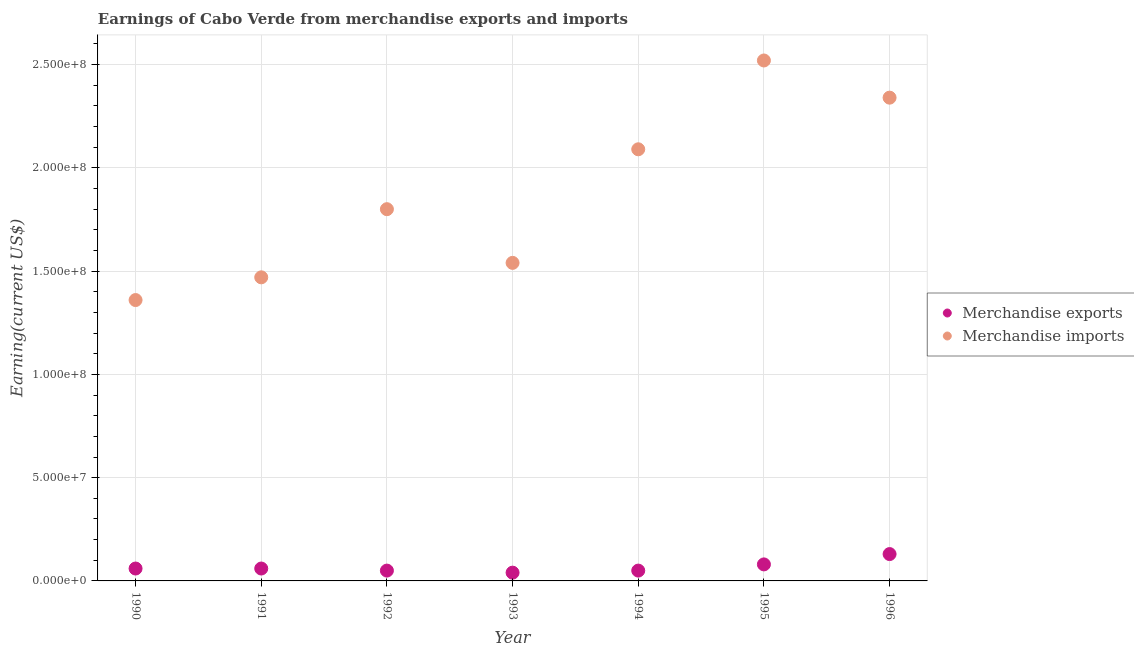How many different coloured dotlines are there?
Your answer should be compact. 2. Is the number of dotlines equal to the number of legend labels?
Make the answer very short. Yes. What is the earnings from merchandise imports in 1991?
Offer a very short reply. 1.47e+08. Across all years, what is the maximum earnings from merchandise exports?
Offer a terse response. 1.30e+07. Across all years, what is the minimum earnings from merchandise exports?
Your answer should be compact. 4.00e+06. In which year was the earnings from merchandise exports maximum?
Ensure brevity in your answer.  1996. In which year was the earnings from merchandise imports minimum?
Your answer should be compact. 1990. What is the total earnings from merchandise imports in the graph?
Your answer should be compact. 1.31e+09. What is the difference between the earnings from merchandise imports in 1992 and that in 1994?
Provide a succinct answer. -2.90e+07. What is the difference between the earnings from merchandise imports in 1990 and the earnings from merchandise exports in 1996?
Offer a very short reply. 1.23e+08. What is the average earnings from merchandise exports per year?
Offer a very short reply. 6.71e+06. In the year 1996, what is the difference between the earnings from merchandise exports and earnings from merchandise imports?
Keep it short and to the point. -2.21e+08. What is the difference between the highest and the lowest earnings from merchandise imports?
Offer a very short reply. 1.16e+08. Is the sum of the earnings from merchandise exports in 1991 and 1996 greater than the maximum earnings from merchandise imports across all years?
Provide a succinct answer. No. Does the earnings from merchandise exports monotonically increase over the years?
Offer a very short reply. No. Is the earnings from merchandise exports strictly less than the earnings from merchandise imports over the years?
Keep it short and to the point. Yes. How many dotlines are there?
Your answer should be very brief. 2. Does the graph contain any zero values?
Ensure brevity in your answer.  No. Where does the legend appear in the graph?
Give a very brief answer. Center right. How many legend labels are there?
Make the answer very short. 2. What is the title of the graph?
Ensure brevity in your answer.  Earnings of Cabo Verde from merchandise exports and imports. What is the label or title of the X-axis?
Your answer should be compact. Year. What is the label or title of the Y-axis?
Offer a terse response. Earning(current US$). What is the Earning(current US$) of Merchandise imports in 1990?
Provide a succinct answer. 1.36e+08. What is the Earning(current US$) in Merchandise imports in 1991?
Your response must be concise. 1.47e+08. What is the Earning(current US$) of Merchandise exports in 1992?
Your answer should be very brief. 5.00e+06. What is the Earning(current US$) in Merchandise imports in 1992?
Ensure brevity in your answer.  1.80e+08. What is the Earning(current US$) of Merchandise exports in 1993?
Your response must be concise. 4.00e+06. What is the Earning(current US$) in Merchandise imports in 1993?
Your answer should be very brief. 1.54e+08. What is the Earning(current US$) of Merchandise imports in 1994?
Provide a succinct answer. 2.09e+08. What is the Earning(current US$) of Merchandise imports in 1995?
Your answer should be compact. 2.52e+08. What is the Earning(current US$) in Merchandise exports in 1996?
Keep it short and to the point. 1.30e+07. What is the Earning(current US$) of Merchandise imports in 1996?
Keep it short and to the point. 2.34e+08. Across all years, what is the maximum Earning(current US$) in Merchandise exports?
Keep it short and to the point. 1.30e+07. Across all years, what is the maximum Earning(current US$) in Merchandise imports?
Ensure brevity in your answer.  2.52e+08. Across all years, what is the minimum Earning(current US$) of Merchandise imports?
Your answer should be compact. 1.36e+08. What is the total Earning(current US$) in Merchandise exports in the graph?
Make the answer very short. 4.70e+07. What is the total Earning(current US$) of Merchandise imports in the graph?
Your answer should be very brief. 1.31e+09. What is the difference between the Earning(current US$) in Merchandise exports in 1990 and that in 1991?
Provide a short and direct response. 0. What is the difference between the Earning(current US$) in Merchandise imports in 1990 and that in 1991?
Provide a short and direct response. -1.10e+07. What is the difference between the Earning(current US$) of Merchandise exports in 1990 and that in 1992?
Ensure brevity in your answer.  1.00e+06. What is the difference between the Earning(current US$) of Merchandise imports in 1990 and that in 1992?
Your answer should be very brief. -4.40e+07. What is the difference between the Earning(current US$) in Merchandise exports in 1990 and that in 1993?
Keep it short and to the point. 2.00e+06. What is the difference between the Earning(current US$) in Merchandise imports in 1990 and that in 1993?
Offer a terse response. -1.80e+07. What is the difference between the Earning(current US$) in Merchandise imports in 1990 and that in 1994?
Your response must be concise. -7.30e+07. What is the difference between the Earning(current US$) in Merchandise imports in 1990 and that in 1995?
Provide a succinct answer. -1.16e+08. What is the difference between the Earning(current US$) in Merchandise exports in 1990 and that in 1996?
Give a very brief answer. -7.00e+06. What is the difference between the Earning(current US$) in Merchandise imports in 1990 and that in 1996?
Your answer should be compact. -9.80e+07. What is the difference between the Earning(current US$) of Merchandise imports in 1991 and that in 1992?
Offer a very short reply. -3.30e+07. What is the difference between the Earning(current US$) in Merchandise exports in 1991 and that in 1993?
Provide a succinct answer. 2.00e+06. What is the difference between the Earning(current US$) in Merchandise imports in 1991 and that in 1993?
Offer a very short reply. -7.00e+06. What is the difference between the Earning(current US$) of Merchandise exports in 1991 and that in 1994?
Provide a short and direct response. 1.00e+06. What is the difference between the Earning(current US$) of Merchandise imports in 1991 and that in 1994?
Make the answer very short. -6.20e+07. What is the difference between the Earning(current US$) of Merchandise exports in 1991 and that in 1995?
Provide a short and direct response. -2.00e+06. What is the difference between the Earning(current US$) of Merchandise imports in 1991 and that in 1995?
Your response must be concise. -1.05e+08. What is the difference between the Earning(current US$) in Merchandise exports in 1991 and that in 1996?
Make the answer very short. -7.00e+06. What is the difference between the Earning(current US$) in Merchandise imports in 1991 and that in 1996?
Offer a very short reply. -8.70e+07. What is the difference between the Earning(current US$) of Merchandise exports in 1992 and that in 1993?
Your response must be concise. 1.00e+06. What is the difference between the Earning(current US$) in Merchandise imports in 1992 and that in 1993?
Offer a very short reply. 2.60e+07. What is the difference between the Earning(current US$) of Merchandise exports in 1992 and that in 1994?
Your response must be concise. 0. What is the difference between the Earning(current US$) of Merchandise imports in 1992 and that in 1994?
Offer a very short reply. -2.90e+07. What is the difference between the Earning(current US$) of Merchandise imports in 1992 and that in 1995?
Offer a very short reply. -7.20e+07. What is the difference between the Earning(current US$) of Merchandise exports in 1992 and that in 1996?
Provide a succinct answer. -8.00e+06. What is the difference between the Earning(current US$) of Merchandise imports in 1992 and that in 1996?
Give a very brief answer. -5.40e+07. What is the difference between the Earning(current US$) in Merchandise imports in 1993 and that in 1994?
Your response must be concise. -5.50e+07. What is the difference between the Earning(current US$) in Merchandise exports in 1993 and that in 1995?
Keep it short and to the point. -4.00e+06. What is the difference between the Earning(current US$) of Merchandise imports in 1993 and that in 1995?
Offer a very short reply. -9.80e+07. What is the difference between the Earning(current US$) of Merchandise exports in 1993 and that in 1996?
Ensure brevity in your answer.  -9.00e+06. What is the difference between the Earning(current US$) of Merchandise imports in 1993 and that in 1996?
Keep it short and to the point. -8.00e+07. What is the difference between the Earning(current US$) of Merchandise exports in 1994 and that in 1995?
Offer a terse response. -3.00e+06. What is the difference between the Earning(current US$) in Merchandise imports in 1994 and that in 1995?
Give a very brief answer. -4.30e+07. What is the difference between the Earning(current US$) of Merchandise exports in 1994 and that in 1996?
Give a very brief answer. -8.00e+06. What is the difference between the Earning(current US$) of Merchandise imports in 1994 and that in 1996?
Ensure brevity in your answer.  -2.50e+07. What is the difference between the Earning(current US$) of Merchandise exports in 1995 and that in 1996?
Keep it short and to the point. -5.00e+06. What is the difference between the Earning(current US$) in Merchandise imports in 1995 and that in 1996?
Provide a short and direct response. 1.80e+07. What is the difference between the Earning(current US$) in Merchandise exports in 1990 and the Earning(current US$) in Merchandise imports in 1991?
Keep it short and to the point. -1.41e+08. What is the difference between the Earning(current US$) in Merchandise exports in 1990 and the Earning(current US$) in Merchandise imports in 1992?
Make the answer very short. -1.74e+08. What is the difference between the Earning(current US$) in Merchandise exports in 1990 and the Earning(current US$) in Merchandise imports in 1993?
Your answer should be very brief. -1.48e+08. What is the difference between the Earning(current US$) in Merchandise exports in 1990 and the Earning(current US$) in Merchandise imports in 1994?
Provide a short and direct response. -2.03e+08. What is the difference between the Earning(current US$) in Merchandise exports in 1990 and the Earning(current US$) in Merchandise imports in 1995?
Your answer should be very brief. -2.46e+08. What is the difference between the Earning(current US$) in Merchandise exports in 1990 and the Earning(current US$) in Merchandise imports in 1996?
Your answer should be compact. -2.28e+08. What is the difference between the Earning(current US$) of Merchandise exports in 1991 and the Earning(current US$) of Merchandise imports in 1992?
Your answer should be very brief. -1.74e+08. What is the difference between the Earning(current US$) in Merchandise exports in 1991 and the Earning(current US$) in Merchandise imports in 1993?
Make the answer very short. -1.48e+08. What is the difference between the Earning(current US$) of Merchandise exports in 1991 and the Earning(current US$) of Merchandise imports in 1994?
Offer a very short reply. -2.03e+08. What is the difference between the Earning(current US$) in Merchandise exports in 1991 and the Earning(current US$) in Merchandise imports in 1995?
Keep it short and to the point. -2.46e+08. What is the difference between the Earning(current US$) of Merchandise exports in 1991 and the Earning(current US$) of Merchandise imports in 1996?
Your answer should be compact. -2.28e+08. What is the difference between the Earning(current US$) in Merchandise exports in 1992 and the Earning(current US$) in Merchandise imports in 1993?
Provide a succinct answer. -1.49e+08. What is the difference between the Earning(current US$) in Merchandise exports in 1992 and the Earning(current US$) in Merchandise imports in 1994?
Offer a very short reply. -2.04e+08. What is the difference between the Earning(current US$) of Merchandise exports in 1992 and the Earning(current US$) of Merchandise imports in 1995?
Offer a very short reply. -2.47e+08. What is the difference between the Earning(current US$) of Merchandise exports in 1992 and the Earning(current US$) of Merchandise imports in 1996?
Offer a terse response. -2.29e+08. What is the difference between the Earning(current US$) of Merchandise exports in 1993 and the Earning(current US$) of Merchandise imports in 1994?
Provide a short and direct response. -2.05e+08. What is the difference between the Earning(current US$) of Merchandise exports in 1993 and the Earning(current US$) of Merchandise imports in 1995?
Ensure brevity in your answer.  -2.48e+08. What is the difference between the Earning(current US$) in Merchandise exports in 1993 and the Earning(current US$) in Merchandise imports in 1996?
Provide a succinct answer. -2.30e+08. What is the difference between the Earning(current US$) of Merchandise exports in 1994 and the Earning(current US$) of Merchandise imports in 1995?
Your response must be concise. -2.47e+08. What is the difference between the Earning(current US$) of Merchandise exports in 1994 and the Earning(current US$) of Merchandise imports in 1996?
Your answer should be very brief. -2.29e+08. What is the difference between the Earning(current US$) in Merchandise exports in 1995 and the Earning(current US$) in Merchandise imports in 1996?
Offer a terse response. -2.26e+08. What is the average Earning(current US$) in Merchandise exports per year?
Provide a short and direct response. 6.71e+06. What is the average Earning(current US$) in Merchandise imports per year?
Your answer should be compact. 1.87e+08. In the year 1990, what is the difference between the Earning(current US$) of Merchandise exports and Earning(current US$) of Merchandise imports?
Keep it short and to the point. -1.30e+08. In the year 1991, what is the difference between the Earning(current US$) of Merchandise exports and Earning(current US$) of Merchandise imports?
Give a very brief answer. -1.41e+08. In the year 1992, what is the difference between the Earning(current US$) of Merchandise exports and Earning(current US$) of Merchandise imports?
Keep it short and to the point. -1.75e+08. In the year 1993, what is the difference between the Earning(current US$) in Merchandise exports and Earning(current US$) in Merchandise imports?
Offer a terse response. -1.50e+08. In the year 1994, what is the difference between the Earning(current US$) of Merchandise exports and Earning(current US$) of Merchandise imports?
Your response must be concise. -2.04e+08. In the year 1995, what is the difference between the Earning(current US$) of Merchandise exports and Earning(current US$) of Merchandise imports?
Offer a very short reply. -2.44e+08. In the year 1996, what is the difference between the Earning(current US$) in Merchandise exports and Earning(current US$) in Merchandise imports?
Give a very brief answer. -2.21e+08. What is the ratio of the Earning(current US$) of Merchandise imports in 1990 to that in 1991?
Your response must be concise. 0.93. What is the ratio of the Earning(current US$) in Merchandise imports in 1990 to that in 1992?
Your answer should be very brief. 0.76. What is the ratio of the Earning(current US$) of Merchandise imports in 1990 to that in 1993?
Give a very brief answer. 0.88. What is the ratio of the Earning(current US$) of Merchandise imports in 1990 to that in 1994?
Give a very brief answer. 0.65. What is the ratio of the Earning(current US$) of Merchandise imports in 1990 to that in 1995?
Your response must be concise. 0.54. What is the ratio of the Earning(current US$) in Merchandise exports in 1990 to that in 1996?
Provide a succinct answer. 0.46. What is the ratio of the Earning(current US$) of Merchandise imports in 1990 to that in 1996?
Your answer should be very brief. 0.58. What is the ratio of the Earning(current US$) in Merchandise exports in 1991 to that in 1992?
Your answer should be compact. 1.2. What is the ratio of the Earning(current US$) of Merchandise imports in 1991 to that in 1992?
Give a very brief answer. 0.82. What is the ratio of the Earning(current US$) in Merchandise imports in 1991 to that in 1993?
Offer a terse response. 0.95. What is the ratio of the Earning(current US$) in Merchandise exports in 1991 to that in 1994?
Your response must be concise. 1.2. What is the ratio of the Earning(current US$) in Merchandise imports in 1991 to that in 1994?
Offer a very short reply. 0.7. What is the ratio of the Earning(current US$) in Merchandise imports in 1991 to that in 1995?
Provide a short and direct response. 0.58. What is the ratio of the Earning(current US$) in Merchandise exports in 1991 to that in 1996?
Provide a succinct answer. 0.46. What is the ratio of the Earning(current US$) in Merchandise imports in 1991 to that in 1996?
Give a very brief answer. 0.63. What is the ratio of the Earning(current US$) in Merchandise imports in 1992 to that in 1993?
Offer a terse response. 1.17. What is the ratio of the Earning(current US$) of Merchandise exports in 1992 to that in 1994?
Your answer should be compact. 1. What is the ratio of the Earning(current US$) in Merchandise imports in 1992 to that in 1994?
Make the answer very short. 0.86. What is the ratio of the Earning(current US$) of Merchandise exports in 1992 to that in 1995?
Your answer should be compact. 0.62. What is the ratio of the Earning(current US$) of Merchandise exports in 1992 to that in 1996?
Offer a very short reply. 0.38. What is the ratio of the Earning(current US$) in Merchandise imports in 1992 to that in 1996?
Provide a succinct answer. 0.77. What is the ratio of the Earning(current US$) of Merchandise exports in 1993 to that in 1994?
Your answer should be compact. 0.8. What is the ratio of the Earning(current US$) of Merchandise imports in 1993 to that in 1994?
Ensure brevity in your answer.  0.74. What is the ratio of the Earning(current US$) in Merchandise imports in 1993 to that in 1995?
Provide a succinct answer. 0.61. What is the ratio of the Earning(current US$) in Merchandise exports in 1993 to that in 1996?
Offer a terse response. 0.31. What is the ratio of the Earning(current US$) of Merchandise imports in 1993 to that in 1996?
Ensure brevity in your answer.  0.66. What is the ratio of the Earning(current US$) of Merchandise imports in 1994 to that in 1995?
Give a very brief answer. 0.83. What is the ratio of the Earning(current US$) in Merchandise exports in 1994 to that in 1996?
Offer a terse response. 0.38. What is the ratio of the Earning(current US$) in Merchandise imports in 1994 to that in 1996?
Your response must be concise. 0.89. What is the ratio of the Earning(current US$) in Merchandise exports in 1995 to that in 1996?
Keep it short and to the point. 0.62. What is the difference between the highest and the second highest Earning(current US$) in Merchandise exports?
Make the answer very short. 5.00e+06. What is the difference between the highest and the second highest Earning(current US$) of Merchandise imports?
Offer a terse response. 1.80e+07. What is the difference between the highest and the lowest Earning(current US$) in Merchandise exports?
Make the answer very short. 9.00e+06. What is the difference between the highest and the lowest Earning(current US$) in Merchandise imports?
Offer a very short reply. 1.16e+08. 